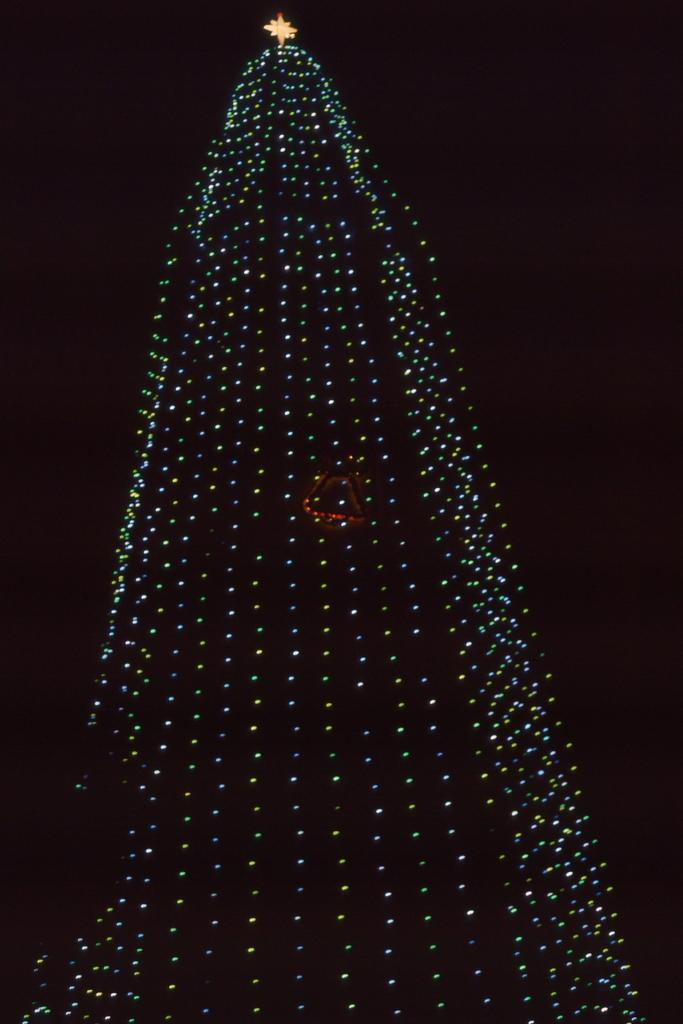What can be seen in the image that provides illumination? There are lights in the image. What is on top of the lights in the image? There is a star on top in the image. What color is the background of the image? The background of the image is black. How does the line contribute to the digestion process in the image? There is no line or reference to digestion present in the image. 